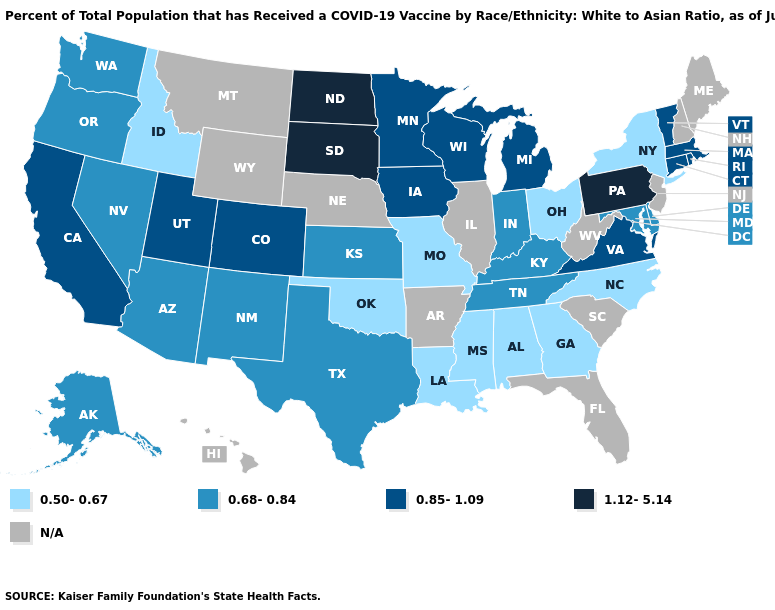What is the lowest value in the West?
Short answer required. 0.50-0.67. What is the value of New York?
Concise answer only. 0.50-0.67. Name the states that have a value in the range 0.50-0.67?
Short answer required. Alabama, Georgia, Idaho, Louisiana, Mississippi, Missouri, New York, North Carolina, Ohio, Oklahoma. What is the value of Nevada?
Give a very brief answer. 0.68-0.84. Name the states that have a value in the range 1.12-5.14?
Give a very brief answer. North Dakota, Pennsylvania, South Dakota. Is the legend a continuous bar?
Write a very short answer. No. What is the value of Tennessee?
Answer briefly. 0.68-0.84. Among the states that border Georgia , which have the lowest value?
Concise answer only. Alabama, North Carolina. Among the states that border Arizona , does New Mexico have the highest value?
Answer briefly. No. Name the states that have a value in the range 0.50-0.67?
Short answer required. Alabama, Georgia, Idaho, Louisiana, Mississippi, Missouri, New York, North Carolina, Ohio, Oklahoma. Name the states that have a value in the range 0.68-0.84?
Give a very brief answer. Alaska, Arizona, Delaware, Indiana, Kansas, Kentucky, Maryland, Nevada, New Mexico, Oregon, Tennessee, Texas, Washington. Which states have the lowest value in the USA?
Quick response, please. Alabama, Georgia, Idaho, Louisiana, Mississippi, Missouri, New York, North Carolina, Ohio, Oklahoma. Does the first symbol in the legend represent the smallest category?
Keep it brief. Yes. Does the map have missing data?
Quick response, please. Yes. 